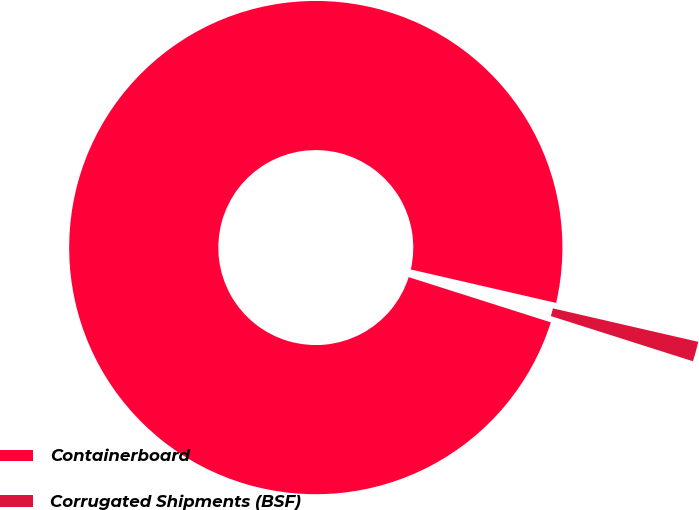<chart> <loc_0><loc_0><loc_500><loc_500><pie_chart><fcel>Containerboard<fcel>Corrugated Shipments (BSF)<nl><fcel>98.7%<fcel>1.3%<nl></chart> 